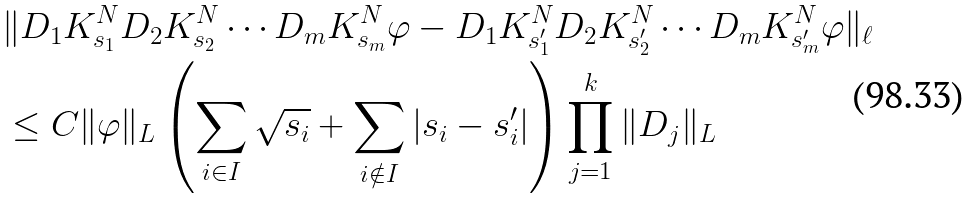Convert formula to latex. <formula><loc_0><loc_0><loc_500><loc_500>& \| D _ { 1 } K _ { s _ { 1 } } ^ { N } D _ { 2 } K _ { s _ { 2 } } ^ { N } \cdots D _ { m } K _ { s _ { m } } ^ { N } \varphi - D _ { 1 } K _ { s _ { 1 } ^ { \prime } } ^ { N } D _ { 2 } K _ { s _ { 2 } ^ { \prime } } ^ { N } \cdots D _ { m } K _ { s _ { m } ^ { \prime } } ^ { N } \varphi \| _ { \ell } \\ & \leq C \| \varphi \| _ { L } \left ( \sum _ { i \in I } \sqrt { s _ { i } } + \sum _ { i \notin I } | s _ { i } - s _ { i } ^ { \prime } | \right ) \prod _ { j = 1 } ^ { k } \| D _ { j } \| _ { L }</formula> 